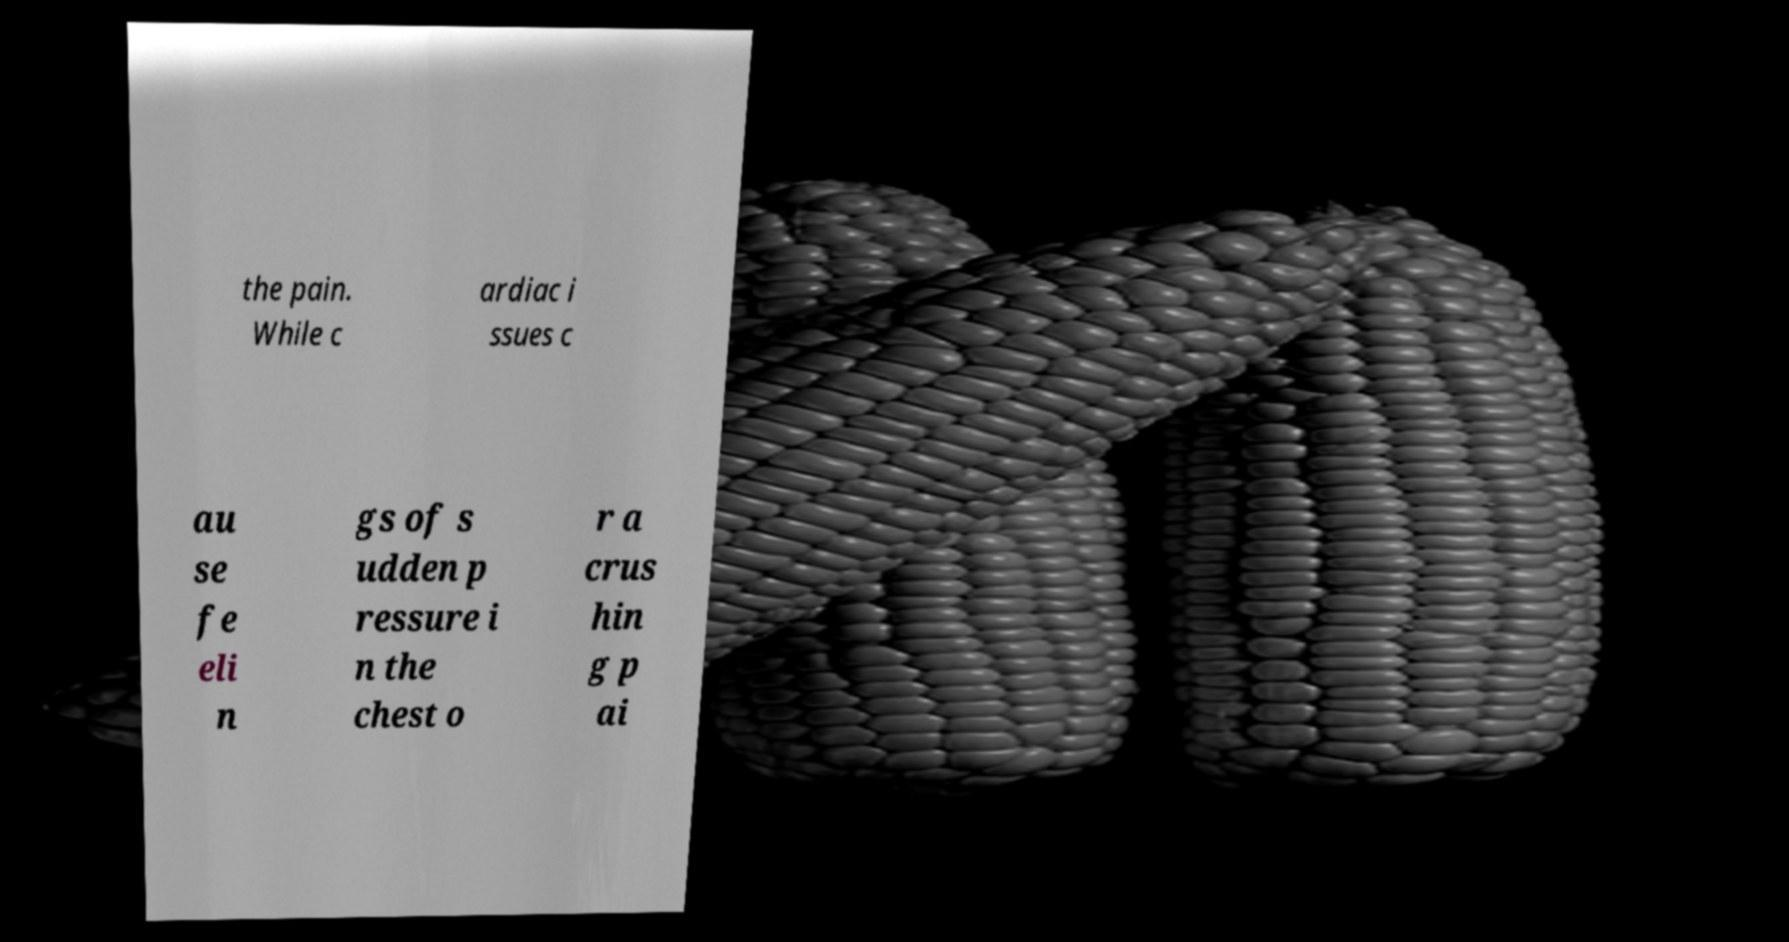I need the written content from this picture converted into text. Can you do that? the pain. While c ardiac i ssues c au se fe eli n gs of s udden p ressure i n the chest o r a crus hin g p ai 